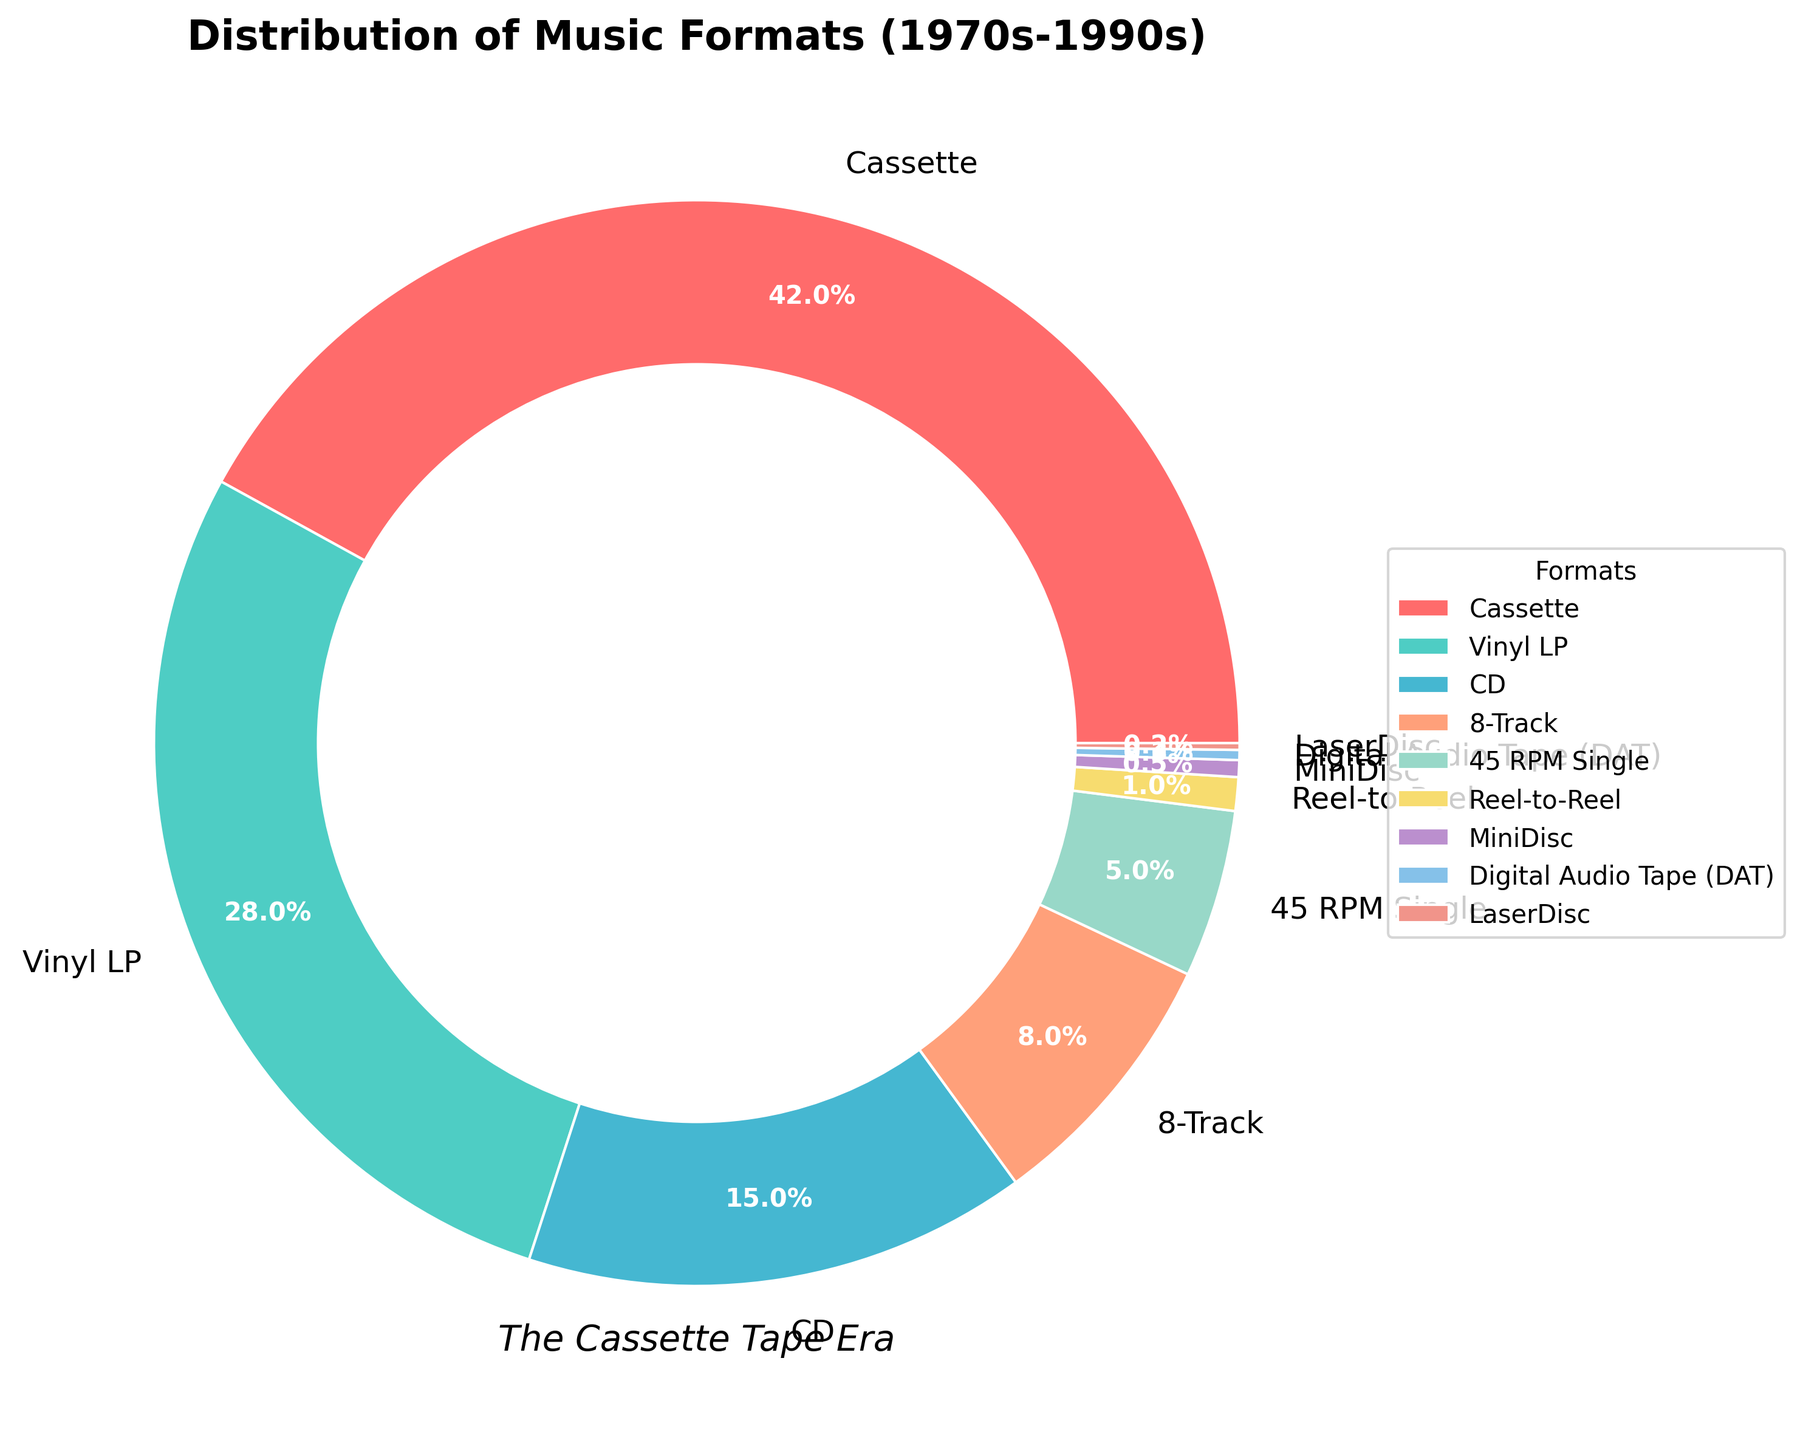What's the most sold music format from the 1970s-1990s? According to the pie chart, the format with the largest wedge is labeled "Cassette." This indicates it had the highest percentage of sales.
Answer: Cassette Which music format had the smallest share of sales? The pie chart's smallest wedge corresponds to "LaserDisc," showing that it had the lowest percentage of sales.
Answer: LaserDisc How does vinyl LP compare to CD in terms of sales percentage? By observing the chart, vinyl LPs have a wedge showing 28%, while CDs show 15%. Comparatively, vinyl LPs had a significantly higher percentage of sales.
Answer: Vinyl LPs had 13% more sales than CDs What's the combined sales percentage of all digital formats (CD, MiniDisc, DAT, LaserDisc)? The sales percentages for digital formats are CD (15%), MiniDisc (0.5%), DAT (0.3%), and LaserDisc (0.2%). Adding these together: 15% + 0.5% + 0.3% + 0.2% equals 16%.
Answer: 16% Which format had a higher sales percentage, 8-Track or 45 RPM Single? Referring to the pie chart, the 8-Track format had 8%, and the 45 RPM Single had 5%. Thus, 8-Track had a higher percentage.
Answer: 8-Track How much more popular were cassettes compared to reel-to-reel tapes? Cassettes account for 42% of sales, while reel-to-reel makes up 1%. Subtracting these values: 42% - 1% equals 41%.
Answer: 41% What’s the percentage difference between the two least popular formats, MiniDisc and DAT? The pie chart indicates MiniDisc had 0.5% and DAT had 0.3%. Subtracting these values gives: 0.5% - 0.3% equates to 0.2%.
Answer: 0.2% What proportion of the total did vinyl LPs, CDs, and cassettes contribute together? Referring to the pie chart, vinyl LPs (28%), CDs (15%), and cassettes (42%) together sum up to: 28% + 15% + 42% equals 85%.
Answer: 85% Identify the format with light blue color and state its sales percentage. The light blue wedge in the pie chart corresponds to "Vinyl LP," with a sales percentage of 28%.
Answer: Vinyl LP, 28% Are there any formats whose sales percentage does not reach 1%? According to the pie chart, MiniDisc (0.5%), DAT (0.3%), and LaserDisc (0.2%) all have percentages under 1%.
Answer: Yes, MiniDisc, DAT, LaserDisc 